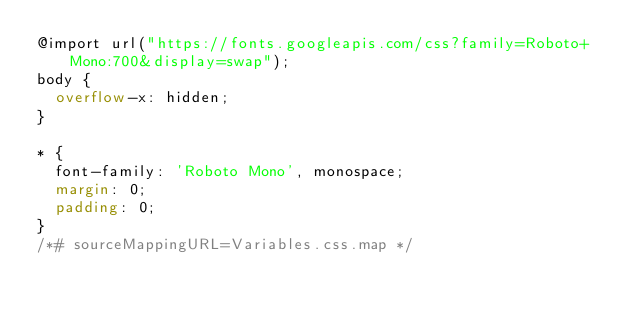<code> <loc_0><loc_0><loc_500><loc_500><_CSS_>@import url("https://fonts.googleapis.com/css?family=Roboto+Mono:700&display=swap");
body {
  overflow-x: hidden;
}

* {
  font-family: 'Roboto Mono', monospace;
  margin: 0;
  padding: 0;
}
/*# sourceMappingURL=Variables.css.map */</code> 